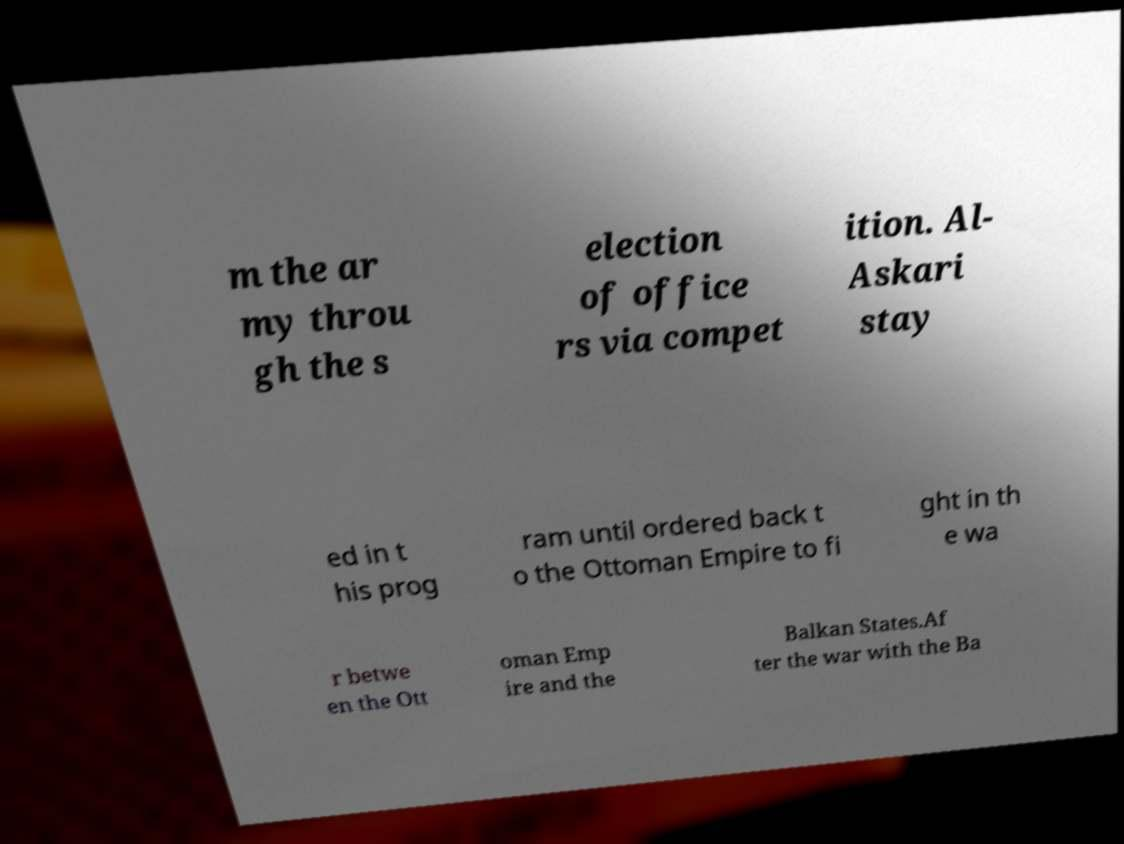Can you accurately transcribe the text from the provided image for me? m the ar my throu gh the s election of office rs via compet ition. Al- Askari stay ed in t his prog ram until ordered back t o the Ottoman Empire to fi ght in th e wa r betwe en the Ott oman Emp ire and the Balkan States.Af ter the war with the Ba 